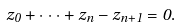Convert formula to latex. <formula><loc_0><loc_0><loc_500><loc_500>z _ { 0 } + \cdot \cdot \cdot + z _ { n } - z _ { n + 1 } = 0 .</formula> 